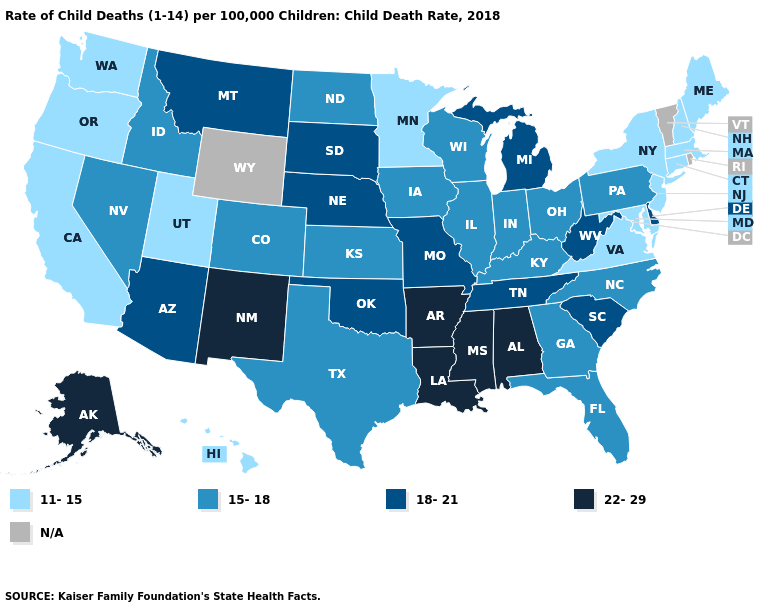What is the value of Kentucky?
Quick response, please. 15-18. Name the states that have a value in the range 11-15?
Keep it brief. California, Connecticut, Hawaii, Maine, Maryland, Massachusetts, Minnesota, New Hampshire, New Jersey, New York, Oregon, Utah, Virginia, Washington. Does the map have missing data?
Write a very short answer. Yes. What is the value of Oregon?
Give a very brief answer. 11-15. Name the states that have a value in the range 11-15?
Short answer required. California, Connecticut, Hawaii, Maine, Maryland, Massachusetts, Minnesota, New Hampshire, New Jersey, New York, Oregon, Utah, Virginia, Washington. What is the value of South Dakota?
Keep it brief. 18-21. Name the states that have a value in the range 15-18?
Concise answer only. Colorado, Florida, Georgia, Idaho, Illinois, Indiana, Iowa, Kansas, Kentucky, Nevada, North Carolina, North Dakota, Ohio, Pennsylvania, Texas, Wisconsin. What is the lowest value in the West?
Write a very short answer. 11-15. What is the value of South Carolina?
Short answer required. 18-21. Name the states that have a value in the range 18-21?
Write a very short answer. Arizona, Delaware, Michigan, Missouri, Montana, Nebraska, Oklahoma, South Carolina, South Dakota, Tennessee, West Virginia. Name the states that have a value in the range 22-29?
Keep it brief. Alabama, Alaska, Arkansas, Louisiana, Mississippi, New Mexico. Among the states that border Georgia , which have the highest value?
Give a very brief answer. Alabama. 